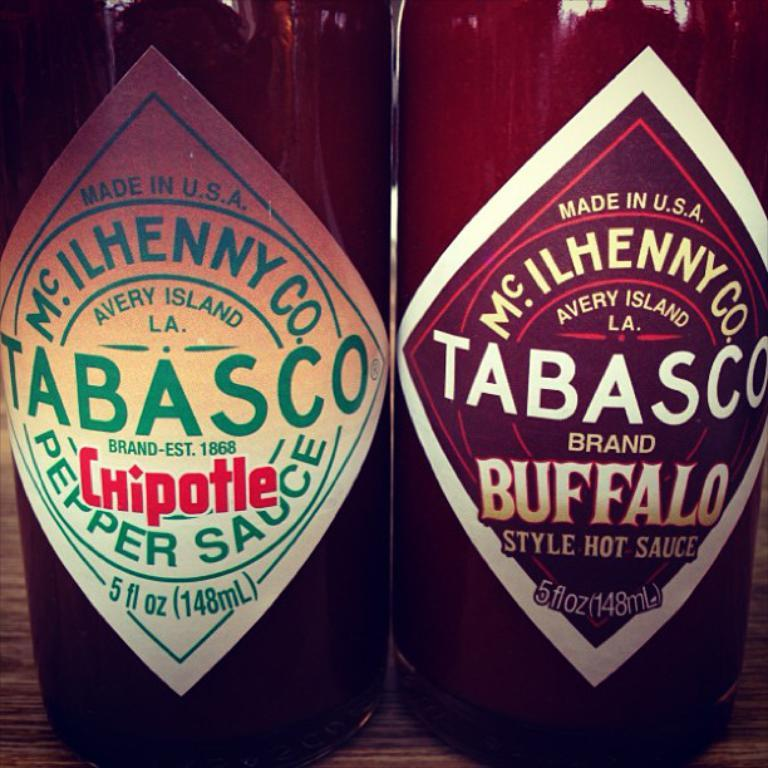How many bottles are visible in the image? There are two bottles in the image. What is on the bottles? The bottles have stickers on them. Where are the bottles located? The bottles are placed on a wooden platform. How does the wooden platform attack the bottles in the image? The wooden platform does not attack the bottles in the image; it simply serves as a surface for the bottles to rest on. 